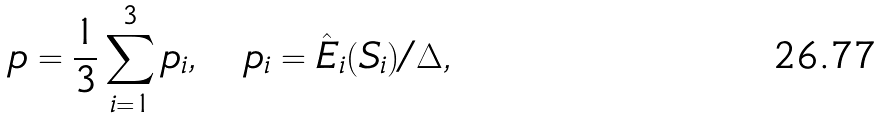Convert formula to latex. <formula><loc_0><loc_0><loc_500><loc_500>p = \frac { 1 } { 3 } \sum _ { i = 1 } ^ { 3 } p _ { i } , \quad p _ { i } = \hat { E } _ { i } ( S _ { i } ) / \Delta ,</formula> 